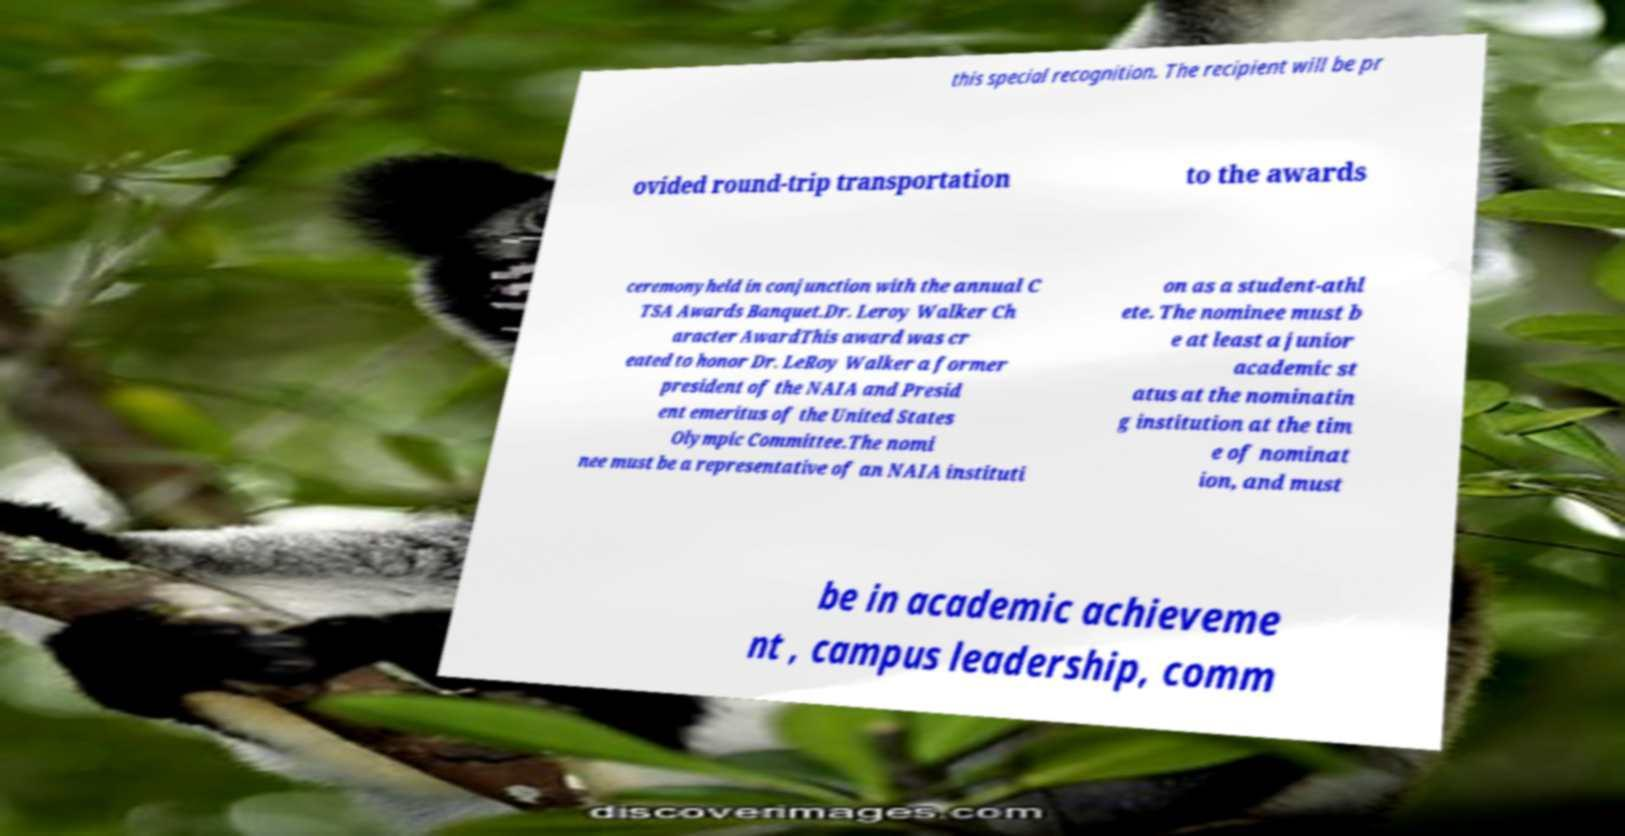For documentation purposes, I need the text within this image transcribed. Could you provide that? this special recognition. The recipient will be pr ovided round-trip transportation to the awards ceremonyheld in conjunction with the annual C TSA Awards Banquet.Dr. Leroy Walker Ch aracter AwardThis award was cr eated to honor Dr. LeRoy Walker a former president of the NAIA and Presid ent emeritus of the United States Olympic Committee.The nomi nee must be a representative of an NAIA instituti on as a student-athl ete. The nominee must b e at least a junior academic st atus at the nominatin g institution at the tim e of nominat ion, and must be in academic achieveme nt , campus leadership, comm 